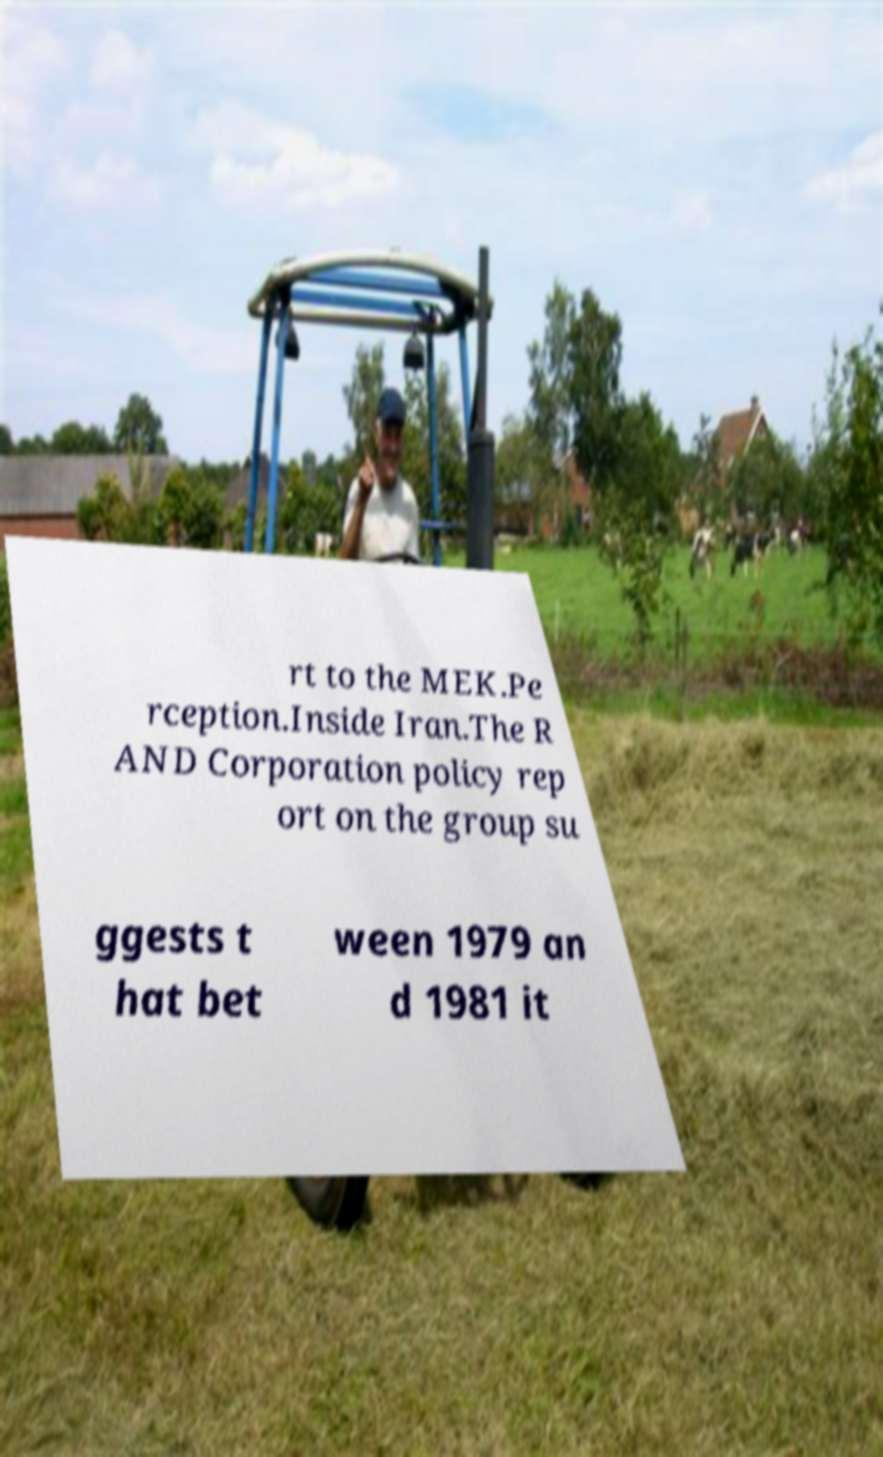For documentation purposes, I need the text within this image transcribed. Could you provide that? rt to the MEK.Pe rception.Inside Iran.The R AND Corporation policy rep ort on the group su ggests t hat bet ween 1979 an d 1981 it 